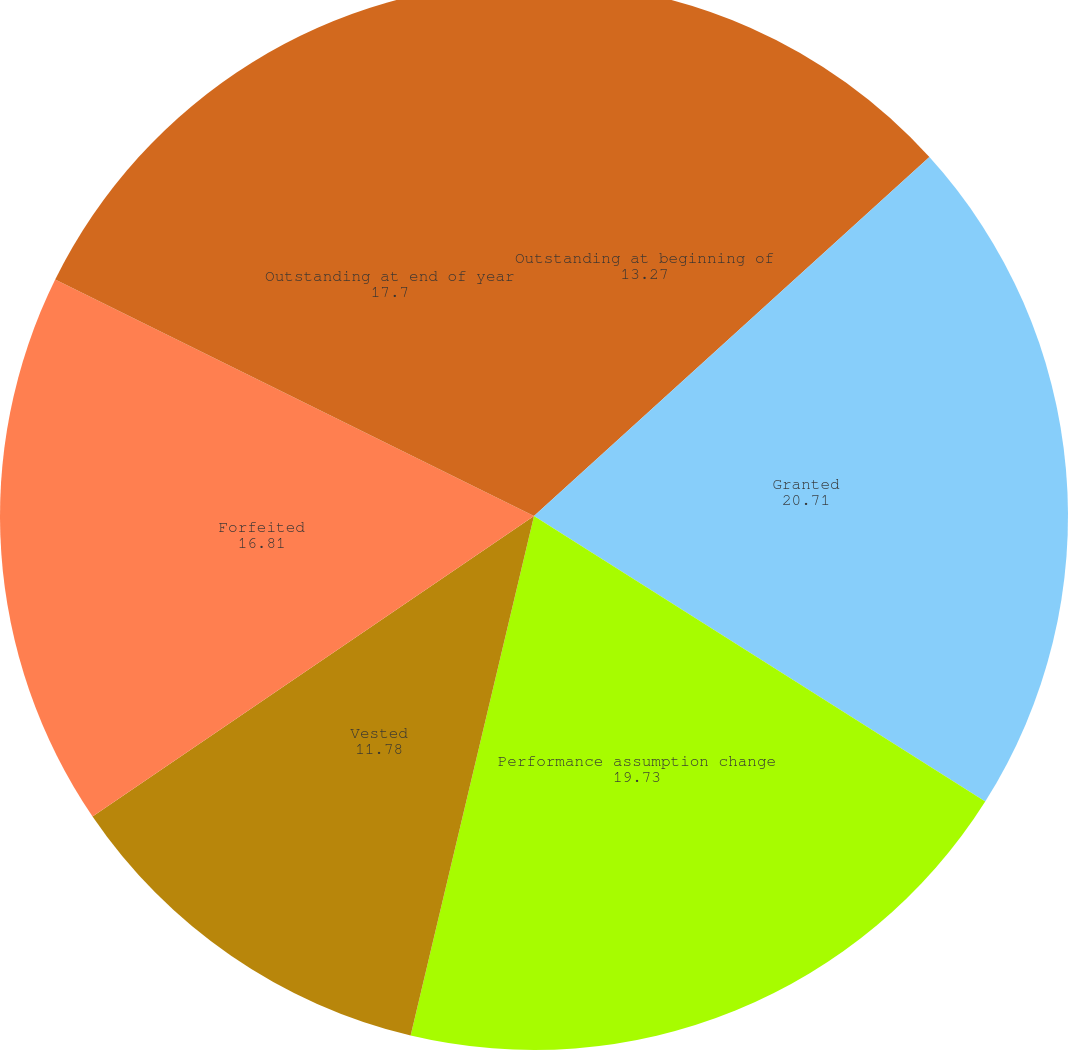<chart> <loc_0><loc_0><loc_500><loc_500><pie_chart><fcel>Outstanding at beginning of<fcel>Granted<fcel>Performance assumption change<fcel>Vested<fcel>Forfeited<fcel>Outstanding at end of year<nl><fcel>13.27%<fcel>20.71%<fcel>19.73%<fcel>11.78%<fcel>16.81%<fcel>17.7%<nl></chart> 